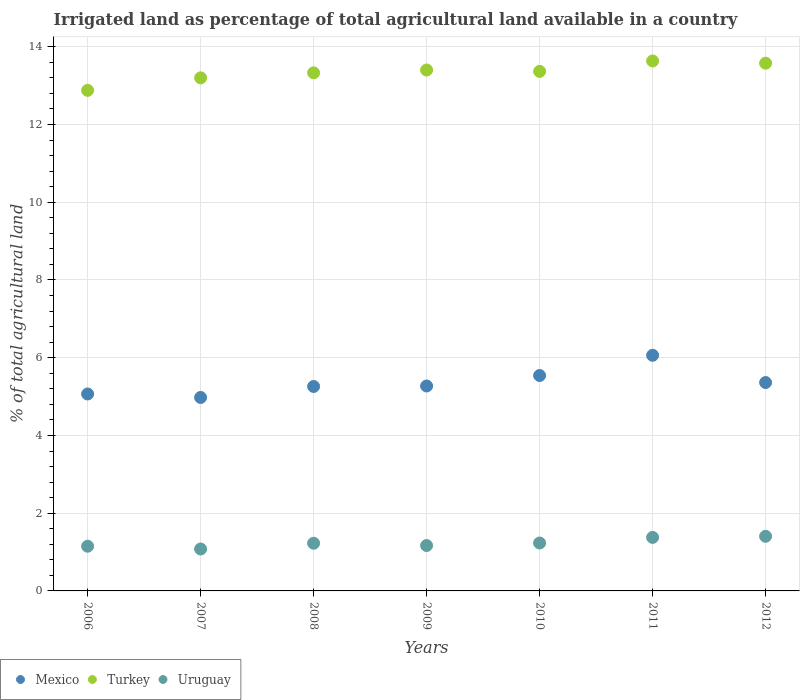How many different coloured dotlines are there?
Your answer should be very brief. 3. What is the percentage of irrigated land in Mexico in 2012?
Make the answer very short. 5.36. Across all years, what is the maximum percentage of irrigated land in Uruguay?
Offer a terse response. 1.41. Across all years, what is the minimum percentage of irrigated land in Uruguay?
Make the answer very short. 1.08. In which year was the percentage of irrigated land in Turkey minimum?
Offer a very short reply. 2006. What is the total percentage of irrigated land in Turkey in the graph?
Your answer should be very brief. 93.39. What is the difference between the percentage of irrigated land in Turkey in 2007 and that in 2008?
Provide a succinct answer. -0.13. What is the difference between the percentage of irrigated land in Mexico in 2008 and the percentage of irrigated land in Uruguay in 2010?
Offer a terse response. 4.03. What is the average percentage of irrigated land in Mexico per year?
Your answer should be very brief. 5.36. In the year 2010, what is the difference between the percentage of irrigated land in Mexico and percentage of irrigated land in Uruguay?
Ensure brevity in your answer.  4.31. In how many years, is the percentage of irrigated land in Uruguay greater than 8.4 %?
Offer a terse response. 0. What is the ratio of the percentage of irrigated land in Mexico in 2008 to that in 2012?
Provide a short and direct response. 0.98. Is the percentage of irrigated land in Mexico in 2006 less than that in 2008?
Provide a succinct answer. Yes. Is the difference between the percentage of irrigated land in Mexico in 2006 and 2008 greater than the difference between the percentage of irrigated land in Uruguay in 2006 and 2008?
Keep it short and to the point. No. What is the difference between the highest and the second highest percentage of irrigated land in Turkey?
Offer a very short reply. 0.06. What is the difference between the highest and the lowest percentage of irrigated land in Mexico?
Provide a short and direct response. 1.09. Is it the case that in every year, the sum of the percentage of irrigated land in Turkey and percentage of irrigated land in Mexico  is greater than the percentage of irrigated land in Uruguay?
Offer a very short reply. Yes. Does the percentage of irrigated land in Turkey monotonically increase over the years?
Your answer should be very brief. No. How many dotlines are there?
Your response must be concise. 3. How many years are there in the graph?
Your answer should be very brief. 7. Does the graph contain any zero values?
Your response must be concise. No. Does the graph contain grids?
Keep it short and to the point. Yes. How many legend labels are there?
Offer a very short reply. 3. What is the title of the graph?
Your answer should be very brief. Irrigated land as percentage of total agricultural land available in a country. What is the label or title of the X-axis?
Your answer should be compact. Years. What is the label or title of the Y-axis?
Give a very brief answer. % of total agricultural land. What is the % of total agricultural land in Mexico in 2006?
Give a very brief answer. 5.07. What is the % of total agricultural land of Turkey in 2006?
Provide a short and direct response. 12.88. What is the % of total agricultural land in Uruguay in 2006?
Ensure brevity in your answer.  1.15. What is the % of total agricultural land in Mexico in 2007?
Your answer should be very brief. 4.98. What is the % of total agricultural land in Turkey in 2007?
Make the answer very short. 13.2. What is the % of total agricultural land of Uruguay in 2007?
Your answer should be compact. 1.08. What is the % of total agricultural land in Mexico in 2008?
Offer a terse response. 5.26. What is the % of total agricultural land of Turkey in 2008?
Provide a short and direct response. 13.33. What is the % of total agricultural land of Uruguay in 2008?
Your response must be concise. 1.23. What is the % of total agricultural land in Mexico in 2009?
Offer a very short reply. 5.27. What is the % of total agricultural land in Turkey in 2009?
Keep it short and to the point. 13.4. What is the % of total agricultural land in Uruguay in 2009?
Your answer should be compact. 1.17. What is the % of total agricultural land of Mexico in 2010?
Your response must be concise. 5.54. What is the % of total agricultural land of Turkey in 2010?
Keep it short and to the point. 13.37. What is the % of total agricultural land in Uruguay in 2010?
Make the answer very short. 1.23. What is the % of total agricultural land in Mexico in 2011?
Offer a very short reply. 6.06. What is the % of total agricultural land of Turkey in 2011?
Provide a succinct answer. 13.64. What is the % of total agricultural land of Uruguay in 2011?
Give a very brief answer. 1.38. What is the % of total agricultural land in Mexico in 2012?
Your response must be concise. 5.36. What is the % of total agricultural land of Turkey in 2012?
Provide a succinct answer. 13.58. What is the % of total agricultural land of Uruguay in 2012?
Ensure brevity in your answer.  1.41. Across all years, what is the maximum % of total agricultural land of Mexico?
Keep it short and to the point. 6.06. Across all years, what is the maximum % of total agricultural land of Turkey?
Offer a terse response. 13.64. Across all years, what is the maximum % of total agricultural land in Uruguay?
Offer a terse response. 1.41. Across all years, what is the minimum % of total agricultural land of Mexico?
Offer a very short reply. 4.98. Across all years, what is the minimum % of total agricultural land of Turkey?
Make the answer very short. 12.88. Across all years, what is the minimum % of total agricultural land of Uruguay?
Keep it short and to the point. 1.08. What is the total % of total agricultural land in Mexico in the graph?
Your answer should be compact. 37.54. What is the total % of total agricultural land in Turkey in the graph?
Offer a very short reply. 93.39. What is the total % of total agricultural land of Uruguay in the graph?
Ensure brevity in your answer.  8.64. What is the difference between the % of total agricultural land in Mexico in 2006 and that in 2007?
Make the answer very short. 0.09. What is the difference between the % of total agricultural land in Turkey in 2006 and that in 2007?
Offer a terse response. -0.32. What is the difference between the % of total agricultural land of Uruguay in 2006 and that in 2007?
Provide a succinct answer. 0.07. What is the difference between the % of total agricultural land of Mexico in 2006 and that in 2008?
Provide a succinct answer. -0.19. What is the difference between the % of total agricultural land in Turkey in 2006 and that in 2008?
Offer a very short reply. -0.45. What is the difference between the % of total agricultural land in Uruguay in 2006 and that in 2008?
Your answer should be very brief. -0.08. What is the difference between the % of total agricultural land in Mexico in 2006 and that in 2009?
Provide a short and direct response. -0.21. What is the difference between the % of total agricultural land of Turkey in 2006 and that in 2009?
Ensure brevity in your answer.  -0.52. What is the difference between the % of total agricultural land of Uruguay in 2006 and that in 2009?
Give a very brief answer. -0.02. What is the difference between the % of total agricultural land in Mexico in 2006 and that in 2010?
Your answer should be very brief. -0.48. What is the difference between the % of total agricultural land in Turkey in 2006 and that in 2010?
Ensure brevity in your answer.  -0.49. What is the difference between the % of total agricultural land in Uruguay in 2006 and that in 2010?
Provide a succinct answer. -0.08. What is the difference between the % of total agricultural land in Mexico in 2006 and that in 2011?
Your answer should be very brief. -1. What is the difference between the % of total agricultural land of Turkey in 2006 and that in 2011?
Make the answer very short. -0.76. What is the difference between the % of total agricultural land in Uruguay in 2006 and that in 2011?
Keep it short and to the point. -0.23. What is the difference between the % of total agricultural land of Mexico in 2006 and that in 2012?
Provide a short and direct response. -0.29. What is the difference between the % of total agricultural land in Turkey in 2006 and that in 2012?
Provide a short and direct response. -0.7. What is the difference between the % of total agricultural land of Uruguay in 2006 and that in 2012?
Offer a terse response. -0.26. What is the difference between the % of total agricultural land in Mexico in 2007 and that in 2008?
Your answer should be very brief. -0.28. What is the difference between the % of total agricultural land in Turkey in 2007 and that in 2008?
Your answer should be very brief. -0.13. What is the difference between the % of total agricultural land of Uruguay in 2007 and that in 2008?
Your response must be concise. -0.15. What is the difference between the % of total agricultural land in Mexico in 2007 and that in 2009?
Your answer should be compact. -0.29. What is the difference between the % of total agricultural land of Turkey in 2007 and that in 2009?
Your answer should be compact. -0.2. What is the difference between the % of total agricultural land of Uruguay in 2007 and that in 2009?
Give a very brief answer. -0.09. What is the difference between the % of total agricultural land in Mexico in 2007 and that in 2010?
Offer a terse response. -0.56. What is the difference between the % of total agricultural land of Turkey in 2007 and that in 2010?
Offer a terse response. -0.17. What is the difference between the % of total agricultural land of Uruguay in 2007 and that in 2010?
Your response must be concise. -0.15. What is the difference between the % of total agricultural land in Mexico in 2007 and that in 2011?
Your response must be concise. -1.08. What is the difference between the % of total agricultural land in Turkey in 2007 and that in 2011?
Your answer should be very brief. -0.43. What is the difference between the % of total agricultural land in Uruguay in 2007 and that in 2011?
Ensure brevity in your answer.  -0.3. What is the difference between the % of total agricultural land of Mexico in 2007 and that in 2012?
Keep it short and to the point. -0.38. What is the difference between the % of total agricultural land in Turkey in 2007 and that in 2012?
Provide a short and direct response. -0.38. What is the difference between the % of total agricultural land of Uruguay in 2007 and that in 2012?
Offer a very short reply. -0.33. What is the difference between the % of total agricultural land of Mexico in 2008 and that in 2009?
Give a very brief answer. -0.01. What is the difference between the % of total agricultural land of Turkey in 2008 and that in 2009?
Your response must be concise. -0.07. What is the difference between the % of total agricultural land of Uruguay in 2008 and that in 2009?
Your answer should be very brief. 0.06. What is the difference between the % of total agricultural land of Mexico in 2008 and that in 2010?
Your answer should be compact. -0.28. What is the difference between the % of total agricultural land in Turkey in 2008 and that in 2010?
Offer a very short reply. -0.04. What is the difference between the % of total agricultural land in Uruguay in 2008 and that in 2010?
Your response must be concise. -0.01. What is the difference between the % of total agricultural land of Mexico in 2008 and that in 2011?
Make the answer very short. -0.8. What is the difference between the % of total agricultural land in Turkey in 2008 and that in 2011?
Keep it short and to the point. -0.3. What is the difference between the % of total agricultural land of Uruguay in 2008 and that in 2011?
Your response must be concise. -0.15. What is the difference between the % of total agricultural land of Mexico in 2008 and that in 2012?
Give a very brief answer. -0.1. What is the difference between the % of total agricultural land of Turkey in 2008 and that in 2012?
Your answer should be compact. -0.25. What is the difference between the % of total agricultural land of Uruguay in 2008 and that in 2012?
Your answer should be very brief. -0.18. What is the difference between the % of total agricultural land of Mexico in 2009 and that in 2010?
Your answer should be very brief. -0.27. What is the difference between the % of total agricultural land in Turkey in 2009 and that in 2010?
Offer a terse response. 0.03. What is the difference between the % of total agricultural land of Uruguay in 2009 and that in 2010?
Ensure brevity in your answer.  -0.07. What is the difference between the % of total agricultural land in Mexico in 2009 and that in 2011?
Ensure brevity in your answer.  -0.79. What is the difference between the % of total agricultural land of Turkey in 2009 and that in 2011?
Offer a very short reply. -0.23. What is the difference between the % of total agricultural land in Uruguay in 2009 and that in 2011?
Your response must be concise. -0.21. What is the difference between the % of total agricultural land of Mexico in 2009 and that in 2012?
Give a very brief answer. -0.09. What is the difference between the % of total agricultural land in Turkey in 2009 and that in 2012?
Give a very brief answer. -0.18. What is the difference between the % of total agricultural land of Uruguay in 2009 and that in 2012?
Your answer should be very brief. -0.24. What is the difference between the % of total agricultural land in Mexico in 2010 and that in 2011?
Offer a terse response. -0.52. What is the difference between the % of total agricultural land in Turkey in 2010 and that in 2011?
Provide a short and direct response. -0.27. What is the difference between the % of total agricultural land of Uruguay in 2010 and that in 2011?
Your answer should be compact. -0.14. What is the difference between the % of total agricultural land in Mexico in 2010 and that in 2012?
Make the answer very short. 0.18. What is the difference between the % of total agricultural land of Turkey in 2010 and that in 2012?
Your answer should be very brief. -0.21. What is the difference between the % of total agricultural land of Uruguay in 2010 and that in 2012?
Give a very brief answer. -0.17. What is the difference between the % of total agricultural land of Mexico in 2011 and that in 2012?
Your response must be concise. 0.7. What is the difference between the % of total agricultural land of Turkey in 2011 and that in 2012?
Offer a very short reply. 0.06. What is the difference between the % of total agricultural land in Uruguay in 2011 and that in 2012?
Provide a short and direct response. -0.03. What is the difference between the % of total agricultural land in Mexico in 2006 and the % of total agricultural land in Turkey in 2007?
Provide a succinct answer. -8.13. What is the difference between the % of total agricultural land of Mexico in 2006 and the % of total agricultural land of Uruguay in 2007?
Provide a short and direct response. 3.99. What is the difference between the % of total agricultural land in Turkey in 2006 and the % of total agricultural land in Uruguay in 2007?
Give a very brief answer. 11.8. What is the difference between the % of total agricultural land in Mexico in 2006 and the % of total agricultural land in Turkey in 2008?
Provide a succinct answer. -8.26. What is the difference between the % of total agricultural land in Mexico in 2006 and the % of total agricultural land in Uruguay in 2008?
Your answer should be compact. 3.84. What is the difference between the % of total agricultural land of Turkey in 2006 and the % of total agricultural land of Uruguay in 2008?
Provide a short and direct response. 11.65. What is the difference between the % of total agricultural land in Mexico in 2006 and the % of total agricultural land in Turkey in 2009?
Offer a very short reply. -8.34. What is the difference between the % of total agricultural land of Mexico in 2006 and the % of total agricultural land of Uruguay in 2009?
Ensure brevity in your answer.  3.9. What is the difference between the % of total agricultural land of Turkey in 2006 and the % of total agricultural land of Uruguay in 2009?
Offer a terse response. 11.71. What is the difference between the % of total agricultural land of Mexico in 2006 and the % of total agricultural land of Turkey in 2010?
Your response must be concise. -8.3. What is the difference between the % of total agricultural land of Mexico in 2006 and the % of total agricultural land of Uruguay in 2010?
Provide a succinct answer. 3.83. What is the difference between the % of total agricultural land in Turkey in 2006 and the % of total agricultural land in Uruguay in 2010?
Ensure brevity in your answer.  11.65. What is the difference between the % of total agricultural land of Mexico in 2006 and the % of total agricultural land of Turkey in 2011?
Ensure brevity in your answer.  -8.57. What is the difference between the % of total agricultural land of Mexico in 2006 and the % of total agricultural land of Uruguay in 2011?
Give a very brief answer. 3.69. What is the difference between the % of total agricultural land in Turkey in 2006 and the % of total agricultural land in Uruguay in 2011?
Keep it short and to the point. 11.5. What is the difference between the % of total agricultural land in Mexico in 2006 and the % of total agricultural land in Turkey in 2012?
Your response must be concise. -8.51. What is the difference between the % of total agricultural land in Mexico in 2006 and the % of total agricultural land in Uruguay in 2012?
Your response must be concise. 3.66. What is the difference between the % of total agricultural land of Turkey in 2006 and the % of total agricultural land of Uruguay in 2012?
Provide a succinct answer. 11.47. What is the difference between the % of total agricultural land of Mexico in 2007 and the % of total agricultural land of Turkey in 2008?
Keep it short and to the point. -8.35. What is the difference between the % of total agricultural land of Mexico in 2007 and the % of total agricultural land of Uruguay in 2008?
Offer a terse response. 3.75. What is the difference between the % of total agricultural land in Turkey in 2007 and the % of total agricultural land in Uruguay in 2008?
Offer a very short reply. 11.97. What is the difference between the % of total agricultural land in Mexico in 2007 and the % of total agricultural land in Turkey in 2009?
Offer a very short reply. -8.42. What is the difference between the % of total agricultural land of Mexico in 2007 and the % of total agricultural land of Uruguay in 2009?
Make the answer very short. 3.81. What is the difference between the % of total agricultural land in Turkey in 2007 and the % of total agricultural land in Uruguay in 2009?
Offer a very short reply. 12.03. What is the difference between the % of total agricultural land of Mexico in 2007 and the % of total agricultural land of Turkey in 2010?
Make the answer very short. -8.39. What is the difference between the % of total agricultural land of Mexico in 2007 and the % of total agricultural land of Uruguay in 2010?
Keep it short and to the point. 3.74. What is the difference between the % of total agricultural land of Turkey in 2007 and the % of total agricultural land of Uruguay in 2010?
Offer a very short reply. 11.97. What is the difference between the % of total agricultural land of Mexico in 2007 and the % of total agricultural land of Turkey in 2011?
Give a very brief answer. -8.66. What is the difference between the % of total agricultural land of Mexico in 2007 and the % of total agricultural land of Uruguay in 2011?
Your answer should be very brief. 3.6. What is the difference between the % of total agricultural land in Turkey in 2007 and the % of total agricultural land in Uruguay in 2011?
Make the answer very short. 11.82. What is the difference between the % of total agricultural land of Mexico in 2007 and the % of total agricultural land of Turkey in 2012?
Your response must be concise. -8.6. What is the difference between the % of total agricultural land of Mexico in 2007 and the % of total agricultural land of Uruguay in 2012?
Offer a terse response. 3.57. What is the difference between the % of total agricultural land in Turkey in 2007 and the % of total agricultural land in Uruguay in 2012?
Give a very brief answer. 11.8. What is the difference between the % of total agricultural land of Mexico in 2008 and the % of total agricultural land of Turkey in 2009?
Ensure brevity in your answer.  -8.14. What is the difference between the % of total agricultural land in Mexico in 2008 and the % of total agricultural land in Uruguay in 2009?
Provide a succinct answer. 4.09. What is the difference between the % of total agricultural land in Turkey in 2008 and the % of total agricultural land in Uruguay in 2009?
Ensure brevity in your answer.  12.16. What is the difference between the % of total agricultural land of Mexico in 2008 and the % of total agricultural land of Turkey in 2010?
Offer a terse response. -8.11. What is the difference between the % of total agricultural land of Mexico in 2008 and the % of total agricultural land of Uruguay in 2010?
Keep it short and to the point. 4.03. What is the difference between the % of total agricultural land of Turkey in 2008 and the % of total agricultural land of Uruguay in 2010?
Your answer should be compact. 12.1. What is the difference between the % of total agricultural land of Mexico in 2008 and the % of total agricultural land of Turkey in 2011?
Give a very brief answer. -8.37. What is the difference between the % of total agricultural land in Mexico in 2008 and the % of total agricultural land in Uruguay in 2011?
Provide a succinct answer. 3.88. What is the difference between the % of total agricultural land in Turkey in 2008 and the % of total agricultural land in Uruguay in 2011?
Make the answer very short. 11.95. What is the difference between the % of total agricultural land in Mexico in 2008 and the % of total agricultural land in Turkey in 2012?
Make the answer very short. -8.32. What is the difference between the % of total agricultural land of Mexico in 2008 and the % of total agricultural land of Uruguay in 2012?
Offer a very short reply. 3.85. What is the difference between the % of total agricultural land in Turkey in 2008 and the % of total agricultural land in Uruguay in 2012?
Provide a succinct answer. 11.92. What is the difference between the % of total agricultural land in Mexico in 2009 and the % of total agricultural land in Turkey in 2010?
Give a very brief answer. -8.1. What is the difference between the % of total agricultural land in Mexico in 2009 and the % of total agricultural land in Uruguay in 2010?
Your answer should be very brief. 4.04. What is the difference between the % of total agricultural land of Turkey in 2009 and the % of total agricultural land of Uruguay in 2010?
Your answer should be very brief. 12.17. What is the difference between the % of total agricultural land in Mexico in 2009 and the % of total agricultural land in Turkey in 2011?
Provide a succinct answer. -8.36. What is the difference between the % of total agricultural land in Mexico in 2009 and the % of total agricultural land in Uruguay in 2011?
Your answer should be compact. 3.9. What is the difference between the % of total agricultural land in Turkey in 2009 and the % of total agricultural land in Uruguay in 2011?
Your response must be concise. 12.03. What is the difference between the % of total agricultural land in Mexico in 2009 and the % of total agricultural land in Turkey in 2012?
Provide a succinct answer. -8.31. What is the difference between the % of total agricultural land in Mexico in 2009 and the % of total agricultural land in Uruguay in 2012?
Offer a terse response. 3.87. What is the difference between the % of total agricultural land of Turkey in 2009 and the % of total agricultural land of Uruguay in 2012?
Keep it short and to the point. 12. What is the difference between the % of total agricultural land of Mexico in 2010 and the % of total agricultural land of Turkey in 2011?
Offer a very short reply. -8.09. What is the difference between the % of total agricultural land in Mexico in 2010 and the % of total agricultural land in Uruguay in 2011?
Provide a succinct answer. 4.17. What is the difference between the % of total agricultural land in Turkey in 2010 and the % of total agricultural land in Uruguay in 2011?
Provide a short and direct response. 11.99. What is the difference between the % of total agricultural land in Mexico in 2010 and the % of total agricultural land in Turkey in 2012?
Give a very brief answer. -8.04. What is the difference between the % of total agricultural land of Mexico in 2010 and the % of total agricultural land of Uruguay in 2012?
Give a very brief answer. 4.14. What is the difference between the % of total agricultural land in Turkey in 2010 and the % of total agricultural land in Uruguay in 2012?
Ensure brevity in your answer.  11.96. What is the difference between the % of total agricultural land in Mexico in 2011 and the % of total agricultural land in Turkey in 2012?
Ensure brevity in your answer.  -7.52. What is the difference between the % of total agricultural land of Mexico in 2011 and the % of total agricultural land of Uruguay in 2012?
Ensure brevity in your answer.  4.66. What is the difference between the % of total agricultural land in Turkey in 2011 and the % of total agricultural land in Uruguay in 2012?
Your response must be concise. 12.23. What is the average % of total agricultural land of Mexico per year?
Offer a terse response. 5.36. What is the average % of total agricultural land of Turkey per year?
Offer a very short reply. 13.34. What is the average % of total agricultural land in Uruguay per year?
Provide a short and direct response. 1.23. In the year 2006, what is the difference between the % of total agricultural land of Mexico and % of total agricultural land of Turkey?
Offer a terse response. -7.81. In the year 2006, what is the difference between the % of total agricultural land of Mexico and % of total agricultural land of Uruguay?
Offer a very short reply. 3.92. In the year 2006, what is the difference between the % of total agricultural land of Turkey and % of total agricultural land of Uruguay?
Your response must be concise. 11.73. In the year 2007, what is the difference between the % of total agricultural land in Mexico and % of total agricultural land in Turkey?
Your response must be concise. -8.22. In the year 2007, what is the difference between the % of total agricultural land of Mexico and % of total agricultural land of Uruguay?
Offer a terse response. 3.9. In the year 2007, what is the difference between the % of total agricultural land of Turkey and % of total agricultural land of Uruguay?
Offer a terse response. 12.12. In the year 2008, what is the difference between the % of total agricultural land of Mexico and % of total agricultural land of Turkey?
Your answer should be very brief. -8.07. In the year 2008, what is the difference between the % of total agricultural land of Mexico and % of total agricultural land of Uruguay?
Your response must be concise. 4.03. In the year 2008, what is the difference between the % of total agricultural land of Turkey and % of total agricultural land of Uruguay?
Your answer should be very brief. 12.1. In the year 2009, what is the difference between the % of total agricultural land in Mexico and % of total agricultural land in Turkey?
Keep it short and to the point. -8.13. In the year 2009, what is the difference between the % of total agricultural land in Mexico and % of total agricultural land in Uruguay?
Make the answer very short. 4.1. In the year 2009, what is the difference between the % of total agricultural land of Turkey and % of total agricultural land of Uruguay?
Make the answer very short. 12.23. In the year 2010, what is the difference between the % of total agricultural land of Mexico and % of total agricultural land of Turkey?
Offer a terse response. -7.83. In the year 2010, what is the difference between the % of total agricultural land in Mexico and % of total agricultural land in Uruguay?
Your answer should be compact. 4.31. In the year 2010, what is the difference between the % of total agricultural land in Turkey and % of total agricultural land in Uruguay?
Make the answer very short. 12.13. In the year 2011, what is the difference between the % of total agricultural land of Mexico and % of total agricultural land of Turkey?
Provide a succinct answer. -7.57. In the year 2011, what is the difference between the % of total agricultural land in Mexico and % of total agricultural land in Uruguay?
Keep it short and to the point. 4.69. In the year 2011, what is the difference between the % of total agricultural land in Turkey and % of total agricultural land in Uruguay?
Provide a short and direct response. 12.26. In the year 2012, what is the difference between the % of total agricultural land in Mexico and % of total agricultural land in Turkey?
Ensure brevity in your answer.  -8.22. In the year 2012, what is the difference between the % of total agricultural land in Mexico and % of total agricultural land in Uruguay?
Provide a short and direct response. 3.96. In the year 2012, what is the difference between the % of total agricultural land in Turkey and % of total agricultural land in Uruguay?
Ensure brevity in your answer.  12.17. What is the ratio of the % of total agricultural land of Mexico in 2006 to that in 2007?
Make the answer very short. 1.02. What is the ratio of the % of total agricultural land in Turkey in 2006 to that in 2007?
Ensure brevity in your answer.  0.98. What is the ratio of the % of total agricultural land of Uruguay in 2006 to that in 2007?
Provide a succinct answer. 1.07. What is the ratio of the % of total agricultural land in Mexico in 2006 to that in 2008?
Give a very brief answer. 0.96. What is the ratio of the % of total agricultural land in Turkey in 2006 to that in 2008?
Provide a short and direct response. 0.97. What is the ratio of the % of total agricultural land of Uruguay in 2006 to that in 2008?
Give a very brief answer. 0.94. What is the ratio of the % of total agricultural land of Mexico in 2006 to that in 2009?
Offer a terse response. 0.96. What is the ratio of the % of total agricultural land in Turkey in 2006 to that in 2009?
Your answer should be compact. 0.96. What is the ratio of the % of total agricultural land in Mexico in 2006 to that in 2010?
Your answer should be compact. 0.91. What is the ratio of the % of total agricultural land in Turkey in 2006 to that in 2010?
Offer a very short reply. 0.96. What is the ratio of the % of total agricultural land of Uruguay in 2006 to that in 2010?
Offer a very short reply. 0.93. What is the ratio of the % of total agricultural land in Mexico in 2006 to that in 2011?
Give a very brief answer. 0.84. What is the ratio of the % of total agricultural land of Turkey in 2006 to that in 2011?
Offer a terse response. 0.94. What is the ratio of the % of total agricultural land of Uruguay in 2006 to that in 2011?
Give a very brief answer. 0.84. What is the ratio of the % of total agricultural land in Mexico in 2006 to that in 2012?
Make the answer very short. 0.95. What is the ratio of the % of total agricultural land of Turkey in 2006 to that in 2012?
Make the answer very short. 0.95. What is the ratio of the % of total agricultural land in Uruguay in 2006 to that in 2012?
Provide a succinct answer. 0.82. What is the ratio of the % of total agricultural land in Mexico in 2007 to that in 2008?
Give a very brief answer. 0.95. What is the ratio of the % of total agricultural land in Turkey in 2007 to that in 2008?
Offer a terse response. 0.99. What is the ratio of the % of total agricultural land of Uruguay in 2007 to that in 2008?
Your answer should be very brief. 0.88. What is the ratio of the % of total agricultural land of Mexico in 2007 to that in 2009?
Ensure brevity in your answer.  0.94. What is the ratio of the % of total agricultural land in Uruguay in 2007 to that in 2009?
Your answer should be very brief. 0.92. What is the ratio of the % of total agricultural land in Mexico in 2007 to that in 2010?
Provide a short and direct response. 0.9. What is the ratio of the % of total agricultural land in Turkey in 2007 to that in 2010?
Your response must be concise. 0.99. What is the ratio of the % of total agricultural land in Uruguay in 2007 to that in 2010?
Provide a short and direct response. 0.87. What is the ratio of the % of total agricultural land of Mexico in 2007 to that in 2011?
Keep it short and to the point. 0.82. What is the ratio of the % of total agricultural land of Turkey in 2007 to that in 2011?
Offer a very short reply. 0.97. What is the ratio of the % of total agricultural land of Uruguay in 2007 to that in 2011?
Provide a succinct answer. 0.78. What is the ratio of the % of total agricultural land in Mexico in 2007 to that in 2012?
Provide a succinct answer. 0.93. What is the ratio of the % of total agricultural land in Turkey in 2007 to that in 2012?
Keep it short and to the point. 0.97. What is the ratio of the % of total agricultural land of Uruguay in 2007 to that in 2012?
Offer a very short reply. 0.77. What is the ratio of the % of total agricultural land of Mexico in 2008 to that in 2009?
Make the answer very short. 1. What is the ratio of the % of total agricultural land in Uruguay in 2008 to that in 2009?
Give a very brief answer. 1.05. What is the ratio of the % of total agricultural land in Mexico in 2008 to that in 2010?
Provide a succinct answer. 0.95. What is the ratio of the % of total agricultural land of Mexico in 2008 to that in 2011?
Offer a terse response. 0.87. What is the ratio of the % of total agricultural land in Turkey in 2008 to that in 2011?
Your answer should be compact. 0.98. What is the ratio of the % of total agricultural land of Uruguay in 2008 to that in 2011?
Keep it short and to the point. 0.89. What is the ratio of the % of total agricultural land of Mexico in 2008 to that in 2012?
Make the answer very short. 0.98. What is the ratio of the % of total agricultural land of Turkey in 2008 to that in 2012?
Keep it short and to the point. 0.98. What is the ratio of the % of total agricultural land in Uruguay in 2008 to that in 2012?
Offer a terse response. 0.87. What is the ratio of the % of total agricultural land in Mexico in 2009 to that in 2010?
Offer a very short reply. 0.95. What is the ratio of the % of total agricultural land in Uruguay in 2009 to that in 2010?
Provide a short and direct response. 0.95. What is the ratio of the % of total agricultural land of Mexico in 2009 to that in 2011?
Provide a succinct answer. 0.87. What is the ratio of the % of total agricultural land of Turkey in 2009 to that in 2011?
Your answer should be compact. 0.98. What is the ratio of the % of total agricultural land of Uruguay in 2009 to that in 2011?
Offer a very short reply. 0.85. What is the ratio of the % of total agricultural land of Mexico in 2009 to that in 2012?
Provide a succinct answer. 0.98. What is the ratio of the % of total agricultural land of Uruguay in 2009 to that in 2012?
Keep it short and to the point. 0.83. What is the ratio of the % of total agricultural land in Mexico in 2010 to that in 2011?
Make the answer very short. 0.91. What is the ratio of the % of total agricultural land in Turkey in 2010 to that in 2011?
Your answer should be compact. 0.98. What is the ratio of the % of total agricultural land of Uruguay in 2010 to that in 2011?
Offer a terse response. 0.9. What is the ratio of the % of total agricultural land of Mexico in 2010 to that in 2012?
Your response must be concise. 1.03. What is the ratio of the % of total agricultural land in Turkey in 2010 to that in 2012?
Ensure brevity in your answer.  0.98. What is the ratio of the % of total agricultural land in Uruguay in 2010 to that in 2012?
Provide a short and direct response. 0.88. What is the ratio of the % of total agricultural land in Mexico in 2011 to that in 2012?
Keep it short and to the point. 1.13. What is the ratio of the % of total agricultural land of Turkey in 2011 to that in 2012?
Provide a short and direct response. 1. What is the ratio of the % of total agricultural land of Uruguay in 2011 to that in 2012?
Keep it short and to the point. 0.98. What is the difference between the highest and the second highest % of total agricultural land of Mexico?
Your response must be concise. 0.52. What is the difference between the highest and the second highest % of total agricultural land in Turkey?
Your answer should be compact. 0.06. What is the difference between the highest and the second highest % of total agricultural land of Uruguay?
Keep it short and to the point. 0.03. What is the difference between the highest and the lowest % of total agricultural land in Mexico?
Give a very brief answer. 1.08. What is the difference between the highest and the lowest % of total agricultural land in Turkey?
Make the answer very short. 0.76. What is the difference between the highest and the lowest % of total agricultural land in Uruguay?
Offer a terse response. 0.33. 